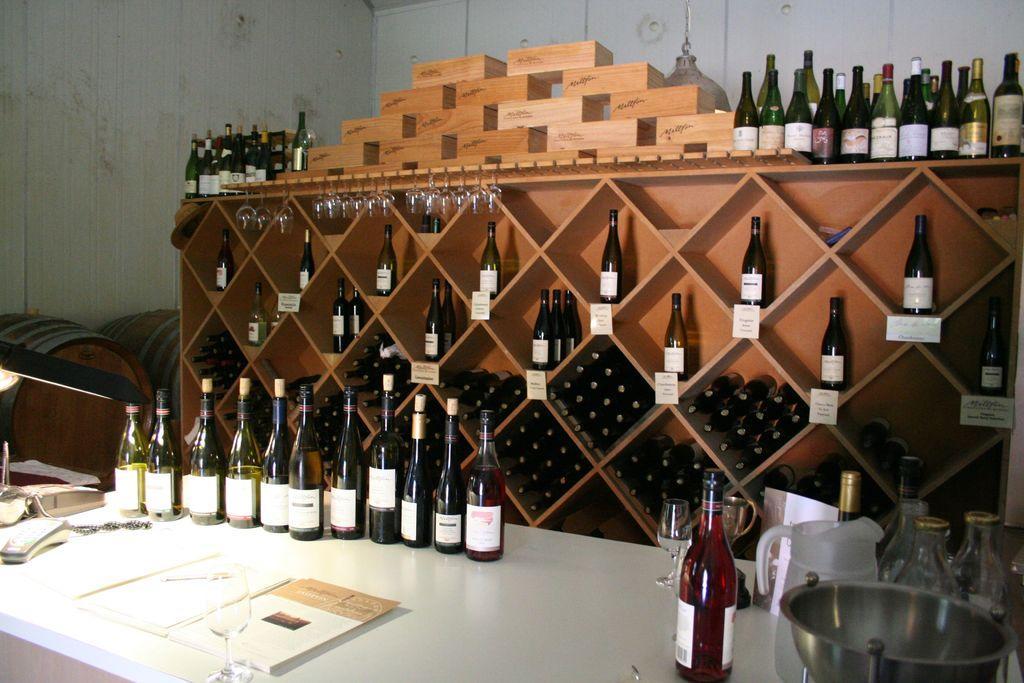In one or two sentences, can you explain what this image depicts? At the bottom of the image we can see a table. On the table we can see the bottles, glasses, mug, vessel, books and some other objects. In the background of the image we can see the drums and rack. In rack we can see the bottles, glasses, boards. At the top of the image we can see the wall. 